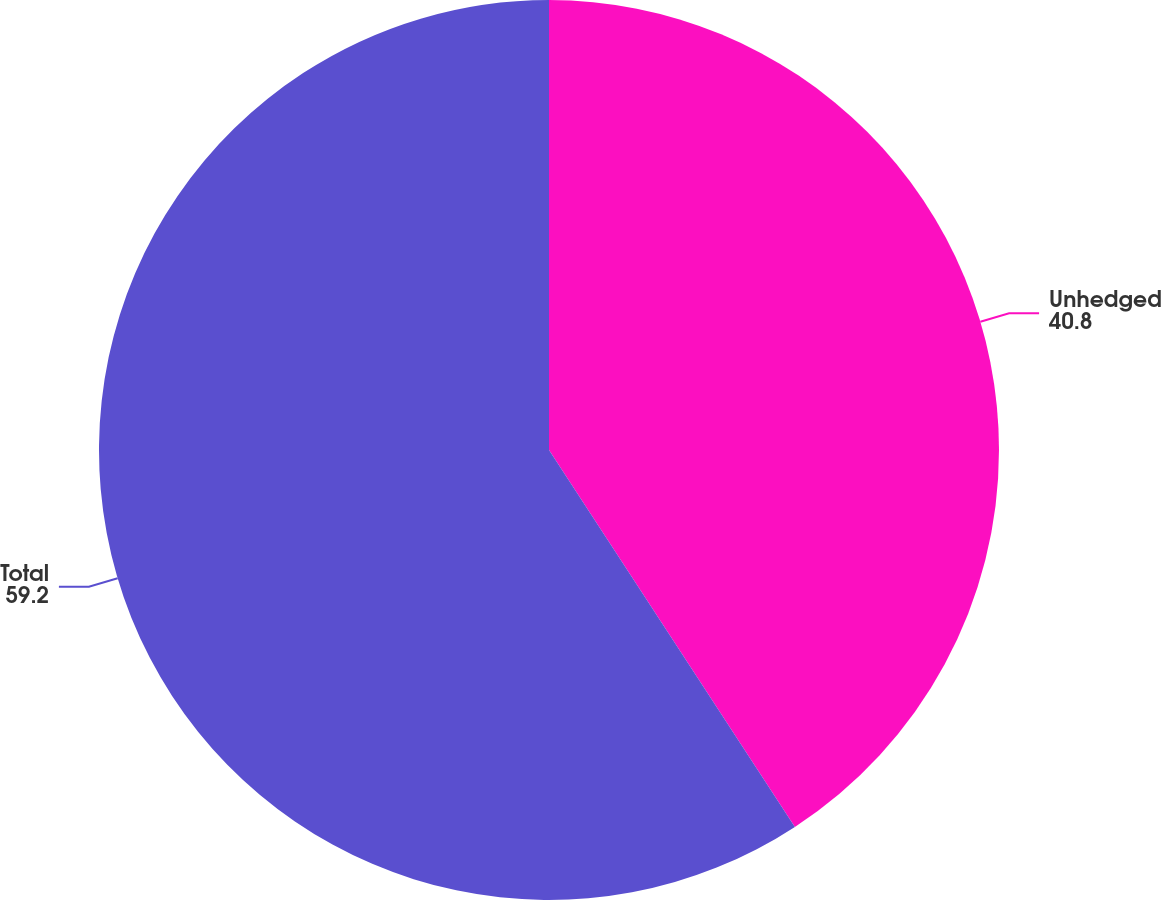Convert chart. <chart><loc_0><loc_0><loc_500><loc_500><pie_chart><fcel>Unhedged<fcel>Total<nl><fcel>40.8%<fcel>59.2%<nl></chart> 